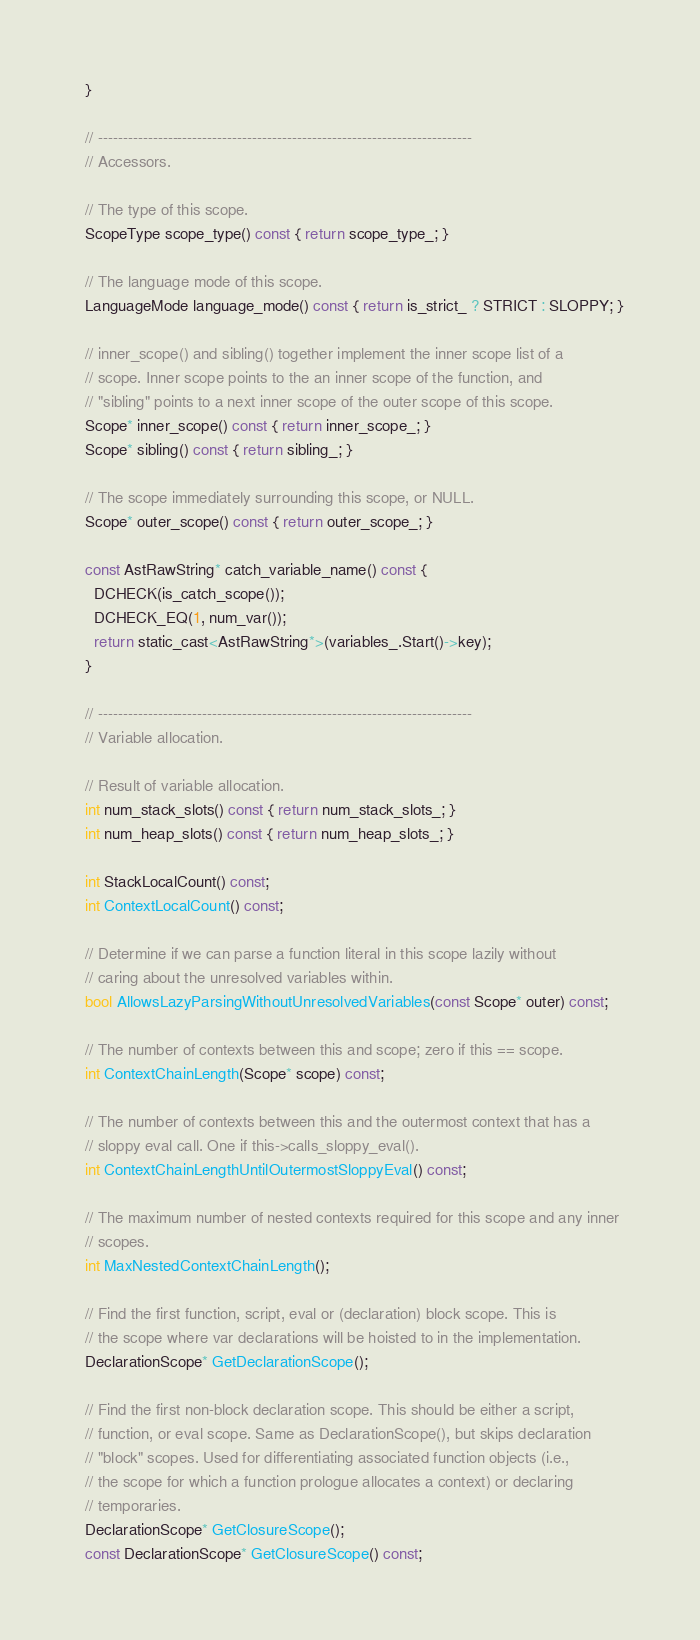<code> <loc_0><loc_0><loc_500><loc_500><_C_>  }

  // ---------------------------------------------------------------------------
  // Accessors.

  // The type of this scope.
  ScopeType scope_type() const { return scope_type_; }

  // The language mode of this scope.
  LanguageMode language_mode() const { return is_strict_ ? STRICT : SLOPPY; }

  // inner_scope() and sibling() together implement the inner scope list of a
  // scope. Inner scope points to the an inner scope of the function, and
  // "sibling" points to a next inner scope of the outer scope of this scope.
  Scope* inner_scope() const { return inner_scope_; }
  Scope* sibling() const { return sibling_; }

  // The scope immediately surrounding this scope, or NULL.
  Scope* outer_scope() const { return outer_scope_; }

  const AstRawString* catch_variable_name() const {
    DCHECK(is_catch_scope());
    DCHECK_EQ(1, num_var());
    return static_cast<AstRawString*>(variables_.Start()->key);
  }

  // ---------------------------------------------------------------------------
  // Variable allocation.

  // Result of variable allocation.
  int num_stack_slots() const { return num_stack_slots_; }
  int num_heap_slots() const { return num_heap_slots_; }

  int StackLocalCount() const;
  int ContextLocalCount() const;

  // Determine if we can parse a function literal in this scope lazily without
  // caring about the unresolved variables within.
  bool AllowsLazyParsingWithoutUnresolvedVariables(const Scope* outer) const;

  // The number of contexts between this and scope; zero if this == scope.
  int ContextChainLength(Scope* scope) const;

  // The number of contexts between this and the outermost context that has a
  // sloppy eval call. One if this->calls_sloppy_eval().
  int ContextChainLengthUntilOutermostSloppyEval() const;

  // The maximum number of nested contexts required for this scope and any inner
  // scopes.
  int MaxNestedContextChainLength();

  // Find the first function, script, eval or (declaration) block scope. This is
  // the scope where var declarations will be hoisted to in the implementation.
  DeclarationScope* GetDeclarationScope();

  // Find the first non-block declaration scope. This should be either a script,
  // function, or eval scope. Same as DeclarationScope(), but skips declaration
  // "block" scopes. Used for differentiating associated function objects (i.e.,
  // the scope for which a function prologue allocates a context) or declaring
  // temporaries.
  DeclarationScope* GetClosureScope();
  const DeclarationScope* GetClosureScope() const;
</code> 